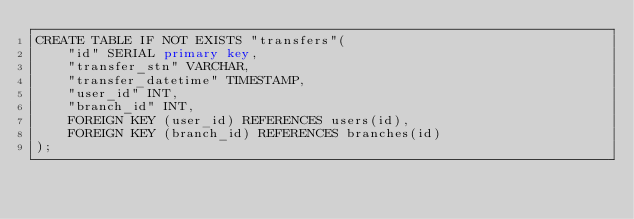<code> <loc_0><loc_0><loc_500><loc_500><_SQL_>CREATE TABLE IF NOT EXISTS "transfers"(
    "id" SERIAL primary key,
    "transfer_stn" VARCHAR,
    "transfer_datetime" TIMESTAMP,
    "user_id" INT,
    "branch_id" INT,
    FOREIGN KEY (user_id) REFERENCES users(id),
    FOREIGN KEY (branch_id) REFERENCES branches(id)
);</code> 